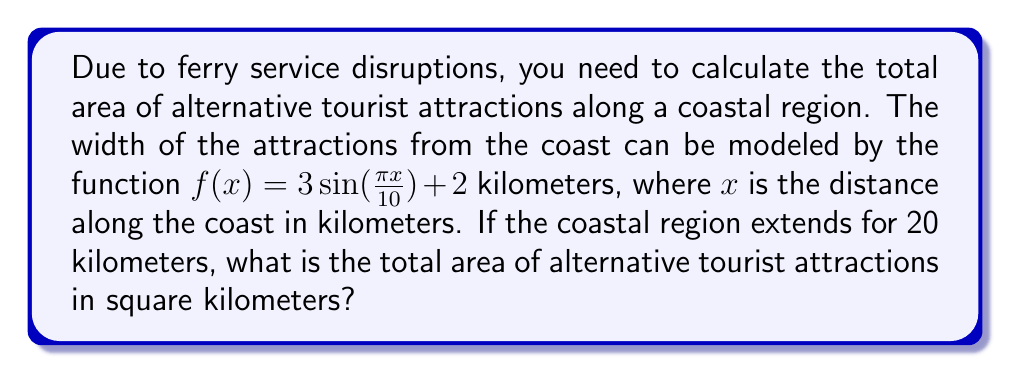Help me with this question. To solve this problem, we need to use definite integration:

1. The area is represented by the integral of the width function $f(x)$ over the given interval.

2. Set up the integral:
   $$A = \int_{0}^{20} f(x) dx = \int_{0}^{20} (3\sin(\frac{\pi x}{10}) + 2) dx$$

3. Split the integral:
   $$A = \int_{0}^{20} 3\sin(\frac{\pi x}{10}) dx + \int_{0}^{20} 2 dx$$

4. Solve the first part using u-substitution:
   Let $u = \frac{\pi x}{10}$, then $du = \frac{\pi}{10} dx$ and $dx = \frac{10}{\pi} du$
   $$\int_{0}^{20} 3\sin(\frac{\pi x}{10}) dx = \frac{30}{\pi} \int_{0}^{2\pi} \sin(u) du = \frac{30}{\pi} [-\cos(u)]_{0}^{2\pi} = \frac{30}{\pi} [(-1) - (-1)] = 0$$

5. Solve the second part:
   $$\int_{0}^{20} 2 dx = 2x \Big|_{0}^{20} = 40$$

6. Sum the results:
   $$A = 0 + 40 = 40$$

Therefore, the total area of alternative tourist attractions is 40 square kilometers.
Answer: 40 square kilometers 